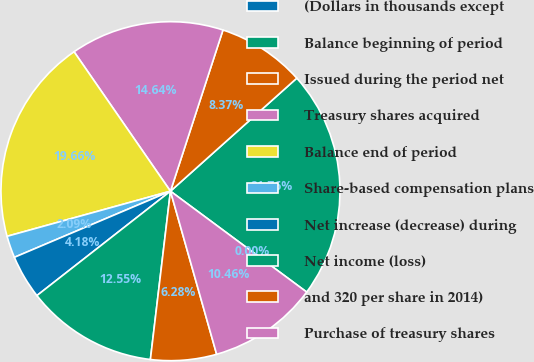<chart> <loc_0><loc_0><loc_500><loc_500><pie_chart><fcel>(Dollars in thousands except<fcel>Balance beginning of period<fcel>Issued during the period net<fcel>Treasury shares acquired<fcel>Balance end of period<fcel>Share-based compensation plans<fcel>Net increase (decrease) during<fcel>Net income (loss)<fcel>and 320 per share in 2014)<fcel>Purchase of treasury shares<nl><fcel>0.0%<fcel>21.76%<fcel>8.37%<fcel>14.64%<fcel>19.66%<fcel>2.09%<fcel>4.18%<fcel>12.55%<fcel>6.28%<fcel>10.46%<nl></chart> 